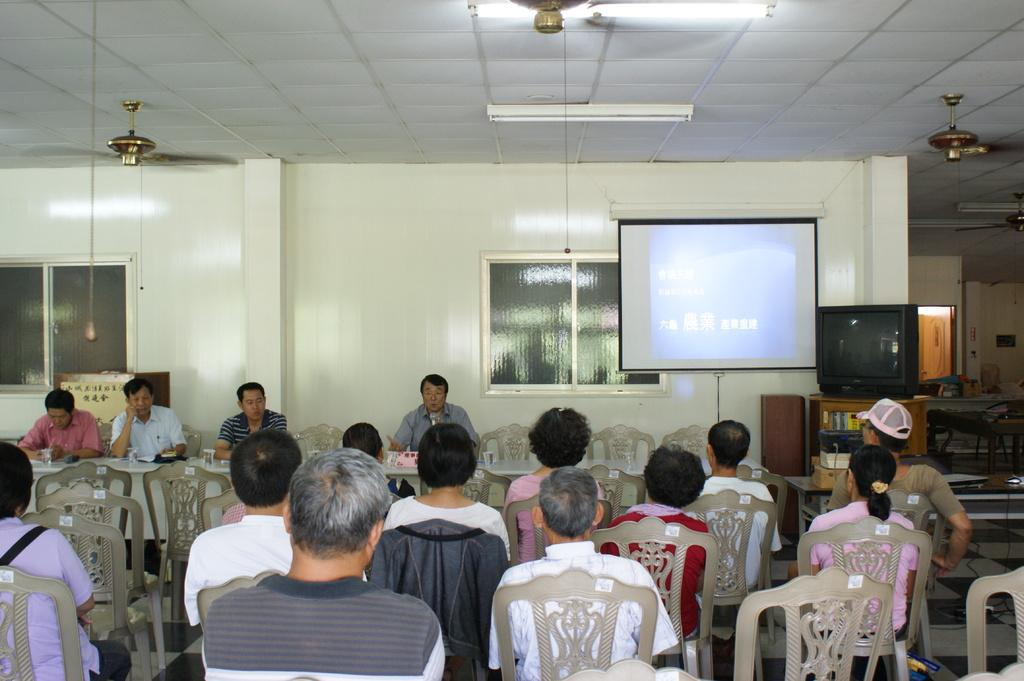What are the people in the image doing? There is a group of people sitting on chairs in front of a table in the image. What is the purpose of the projector screen in the image? The projector screen is likely used for presentations or displaying visuals during a meeting or event. What can be seen in the image to provide ventilation or cooling? There are fans visible in the image. What electronic device is present on the table in the image? There is a TV on the table in the image. What type of frame is used to support the actor in the image? There is no actor or frame present in the image; it features a group of people sitting on chairs in front of a table, a projector screen, fans, and a TV. 